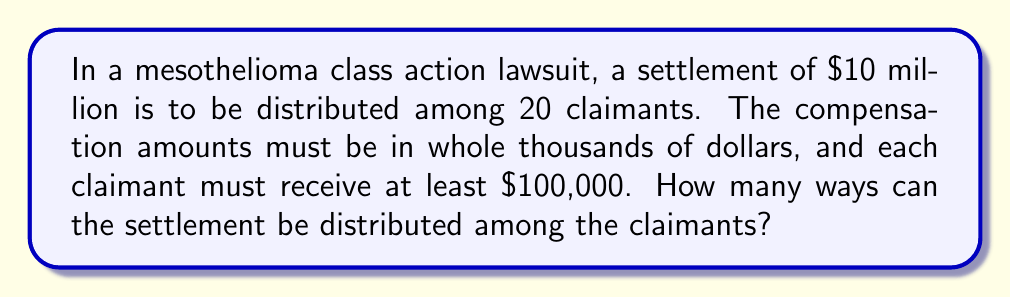Could you help me with this problem? Let's approach this step-by-step:

1) First, we need to calculate the amount available for distribution after ensuring each claimant receives the minimum $100,000:
   $10,000,000 - (20 \times 100,000) = 8,000,000$

2) So, we need to distribute $8,000,000 among 20 claimants, in multiples of $1,000.
   This is equivalent to distributing 8,000 units among 20 claimants.

3) This scenario can be modeled as a stars and bars problem in combinatorics.
   We have 8,000 identical objects (stars) to be placed into 20 distinct boxes (claimants).

4) The formula for this scenario is:
   $$\binom{n+k-1}{k-1}$$
   where $n$ is the number of identical objects and $k$ is the number of distinct boxes.

5) In our case, $n = 8000$ and $k = 20$. So we need to calculate:
   $$\binom{8000+20-1}{20-1} = \binom{8019}{19}$$

6) This can be calculated as:
   $$\frac{8019!}{19!(8000)!}$$

7) Due to the large numbers involved, this is best calculated using software or a scientific calculator.
Answer: $\binom{8019}{19}$ 